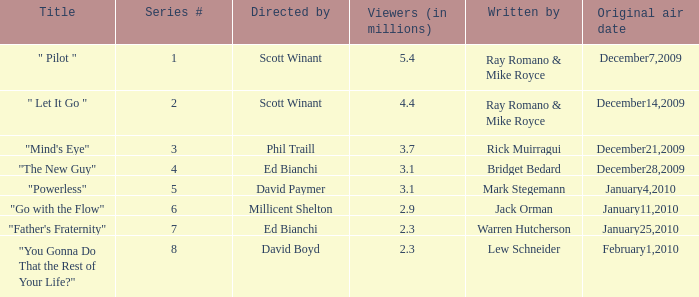What is the episode number of  "you gonna do that the rest of your life?" 8.0. 